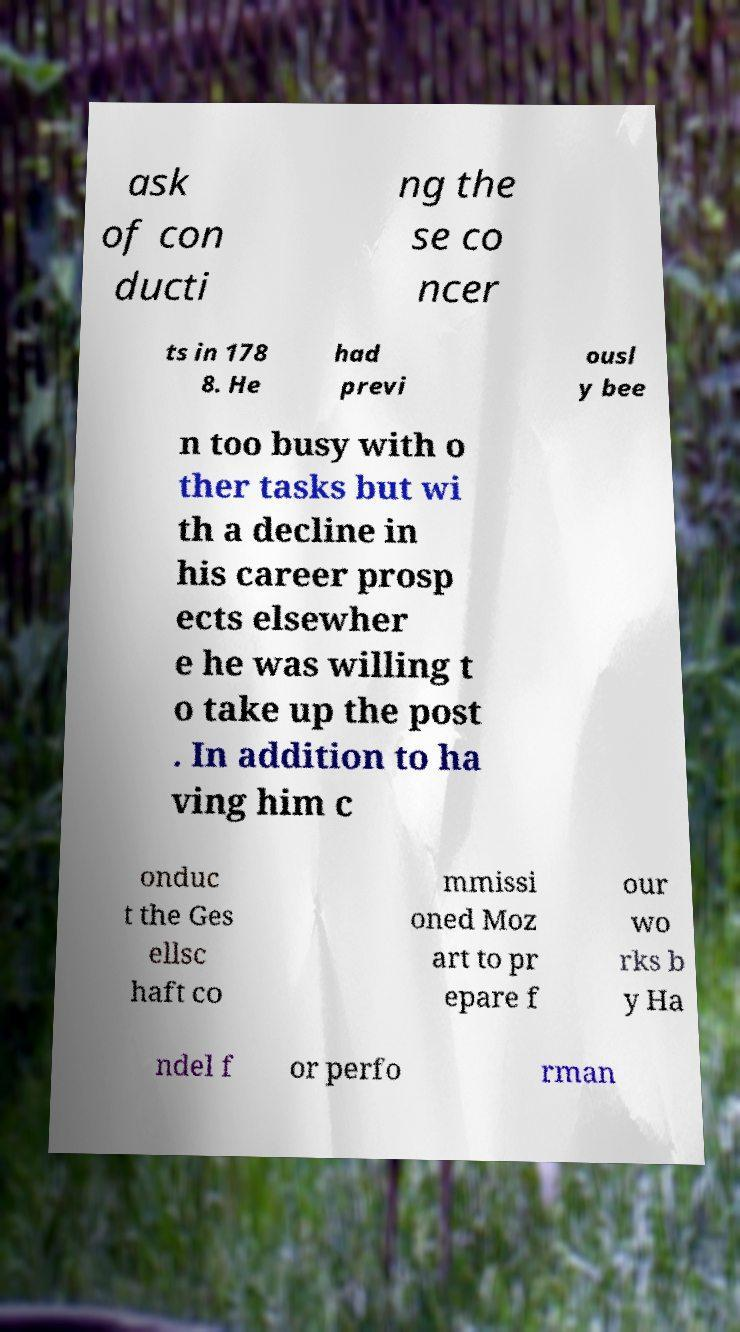There's text embedded in this image that I need extracted. Can you transcribe it verbatim? ask of con ducti ng the se co ncer ts in 178 8. He had previ ousl y bee n too busy with o ther tasks but wi th a decline in his career prosp ects elsewher e he was willing t o take up the post . In addition to ha ving him c onduc t the Ges ellsc haft co mmissi oned Moz art to pr epare f our wo rks b y Ha ndel f or perfo rman 